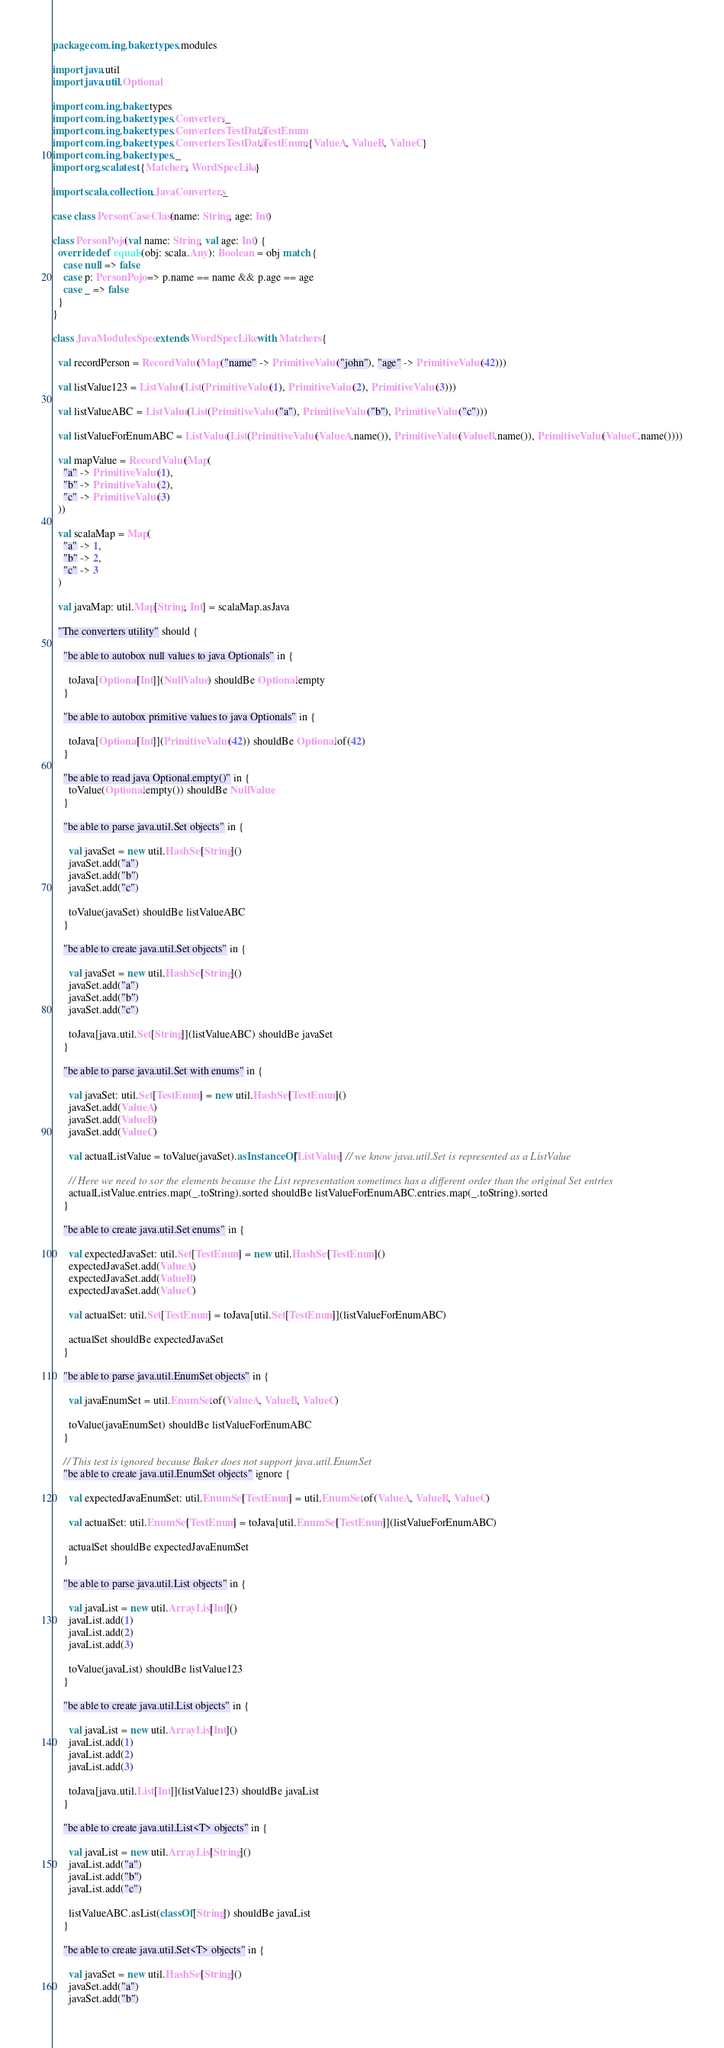<code> <loc_0><loc_0><loc_500><loc_500><_Scala_>package com.ing.baker.types.modules

import java.util
import java.util.Optional

import com.ing.baker.types
import com.ing.baker.types.Converters._
import com.ing.baker.types.ConvertersTestData.TestEnum
import com.ing.baker.types.ConvertersTestData.TestEnum.{ValueA, ValueB, ValueC}
import com.ing.baker.types._
import org.scalatest.{Matchers, WordSpecLike}

import scala.collection.JavaConverters._

case class PersonCaseClass(name: String, age: Int)

class PersonPojo(val name: String, val age: Int) {
  override def equals(obj: scala.Any): Boolean = obj match {
    case null => false
    case p: PersonPojo => p.name == name && p.age == age
    case _ => false
  }
}

class JavaModulesSpec extends WordSpecLike with Matchers {

  val recordPerson = RecordValue(Map("name" -> PrimitiveValue("john"), "age" -> PrimitiveValue(42)))

  val listValue123 = ListValue(List(PrimitiveValue(1), PrimitiveValue(2), PrimitiveValue(3)))

  val listValueABC = ListValue(List(PrimitiveValue("a"), PrimitiveValue("b"), PrimitiveValue("c")))

  val listValueForEnumABC = ListValue(List(PrimitiveValue(ValueA.name()), PrimitiveValue(ValueB.name()), PrimitiveValue(ValueC.name())))

  val mapValue = RecordValue(Map(
    "a" -> PrimitiveValue(1),
    "b" -> PrimitiveValue(2),
    "c" -> PrimitiveValue(3)
  ))

  val scalaMap = Map(
    "a" -> 1,
    "b" -> 2,
    "c" -> 3
  )

  val javaMap: util.Map[String, Int] = scalaMap.asJava

  "The converters utility" should {

    "be able to autobox null values to java Optionals" in {

      toJava[Optional[Int]](NullValue) shouldBe Optional.empty
    }

    "be able to autobox primitive values to java Optionals" in {

      toJava[Optional[Int]](PrimitiveValue(42)) shouldBe Optional.of(42)
    }

    "be able to read java Optional.empty()" in {
      toValue(Optional.empty()) shouldBe NullValue
    }

    "be able to parse java.util.Set objects" in {

      val javaSet = new util.HashSet[String]()
      javaSet.add("a")
      javaSet.add("b")
      javaSet.add("c")

      toValue(javaSet) shouldBe listValueABC
    }

    "be able to create java.util.Set objects" in {

      val javaSet = new util.HashSet[String]()
      javaSet.add("a")
      javaSet.add("b")
      javaSet.add("c")

      toJava[java.util.Set[String]](listValueABC) shouldBe javaSet
    }

    "be able to parse java.util.Set with enums" in {

      val javaSet: util.Set[TestEnum] = new util.HashSet[TestEnum]()
      javaSet.add(ValueA)
      javaSet.add(ValueB)
      javaSet.add(ValueC)

      val actualListValue = toValue(javaSet).asInstanceOf[ListValue] // we know java.util.Set is represented as a ListValue

      // Here we need to sor the elements because the List representation sometimes has a different order than the original Set entries
      actualListValue.entries.map(_.toString).sorted shouldBe listValueForEnumABC.entries.map(_.toString).sorted
    }

    "be able to create java.util.Set enums" in {

      val expectedJavaSet: util.Set[TestEnum] = new util.HashSet[TestEnum]()
      expectedJavaSet.add(ValueA)
      expectedJavaSet.add(ValueB)
      expectedJavaSet.add(ValueC)

      val actualSet: util.Set[TestEnum] = toJava[util.Set[TestEnum]](listValueForEnumABC)

      actualSet shouldBe expectedJavaSet
    }

    "be able to parse java.util.EnumSet objects" in {

      val javaEnumSet = util.EnumSet.of(ValueA, ValueB, ValueC)

      toValue(javaEnumSet) shouldBe listValueForEnumABC
    }

    // This test is ignored because Baker does not support java.util.EnumSet
    "be able to create java.util.EnumSet objects" ignore {

      val expectedJavaEnumSet: util.EnumSet[TestEnum] = util.EnumSet.of(ValueA, ValueB, ValueC)

      val actualSet: util.EnumSet[TestEnum] = toJava[util.EnumSet[TestEnum]](listValueForEnumABC)

      actualSet shouldBe expectedJavaEnumSet
    }

    "be able to parse java.util.List objects" in {

      val javaList = new util.ArrayList[Int]()
      javaList.add(1)
      javaList.add(2)
      javaList.add(3)

      toValue(javaList) shouldBe listValue123
    }

    "be able to create java.util.List objects" in {

      val javaList = new util.ArrayList[Int]()
      javaList.add(1)
      javaList.add(2)
      javaList.add(3)

      toJava[java.util.List[Int]](listValue123) shouldBe javaList
    }

    "be able to create java.util.List<T> objects" in {

      val javaList = new util.ArrayList[String]()
      javaList.add("a")
      javaList.add("b")
      javaList.add("c")

      listValueABC.asList(classOf[String]) shouldBe javaList
    }

    "be able to create java.util.Set<T> objects" in {

      val javaSet = new util.HashSet[String]()
      javaSet.add("a")
      javaSet.add("b")</code> 